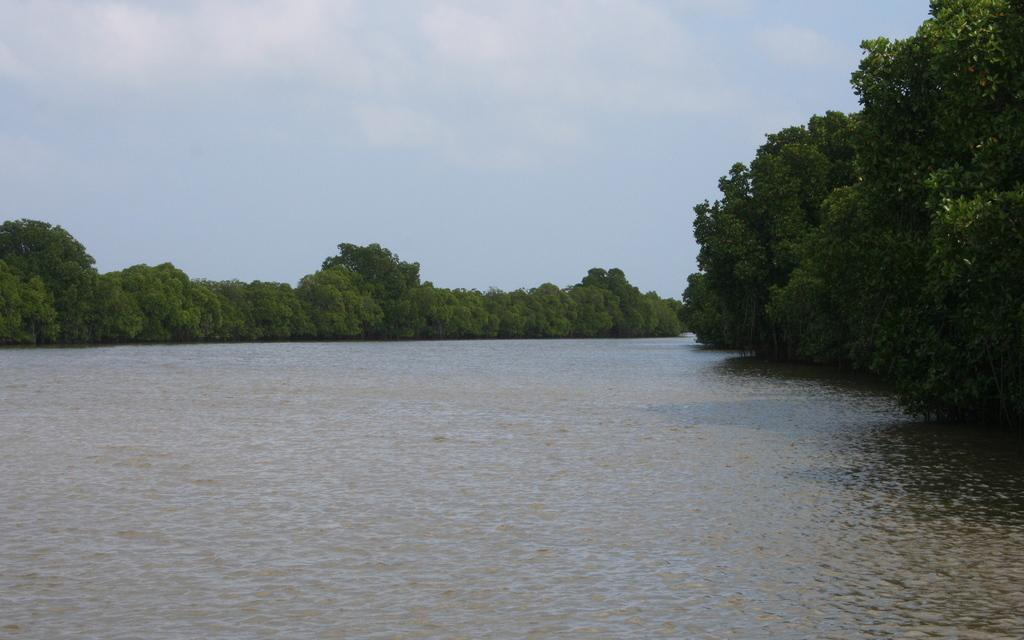What is the primary element visible in the picture? There is water in the picture. What type of vegetation can be seen near the water? There are trees on either side of the water. What type of glass can be seen floating in the water? There is no glass visible in the water in the image. 